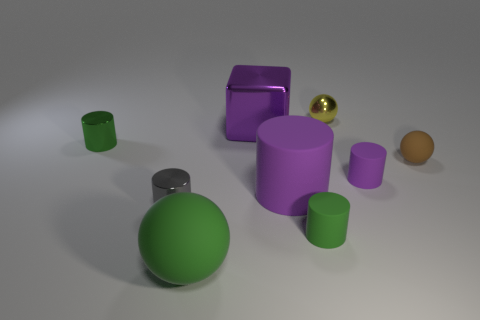Subtract all gray cylinders. How many cylinders are left? 4 Subtract all tiny green shiny cylinders. How many cylinders are left? 4 Subtract all brown cylinders. Subtract all yellow spheres. How many cylinders are left? 5 Add 1 tiny green shiny things. How many objects exist? 10 Subtract all cylinders. How many objects are left? 4 Add 3 metallic cylinders. How many metallic cylinders exist? 5 Subtract 0 brown cubes. How many objects are left? 9 Subtract all tiny green shiny objects. Subtract all big red objects. How many objects are left? 8 Add 6 big purple matte cylinders. How many big purple matte cylinders are left? 7 